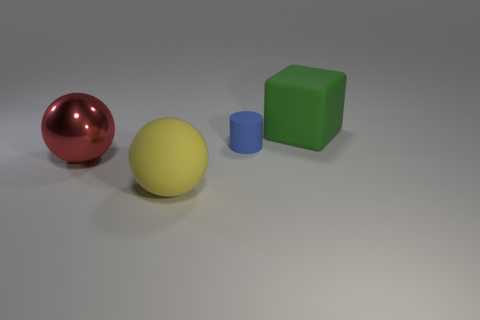How many things are either metal objects or spheres on the left side of the blue rubber object?
Your response must be concise. 2. Is the color of the rubber cylinder the same as the big metal ball?
Make the answer very short. No. Is there another green thing that has the same material as the big green thing?
Give a very brief answer. No. There is a rubber object that is the same shape as the big red shiny thing; what color is it?
Ensure brevity in your answer.  Yellow. Are the yellow sphere and the large sphere behind the large yellow sphere made of the same material?
Offer a terse response. No. There is a large object that is on the left side of the large rubber thing in front of the green object; what is its shape?
Your response must be concise. Sphere. Do the blue thing that is behind the yellow sphere and the large yellow object have the same size?
Your answer should be compact. No. How many other objects are there of the same shape as the green rubber thing?
Provide a short and direct response. 0. There is a large ball that is on the left side of the big yellow matte thing; is its color the same as the rubber block?
Offer a terse response. No. Is there a matte thing that has the same color as the matte block?
Give a very brief answer. No. 